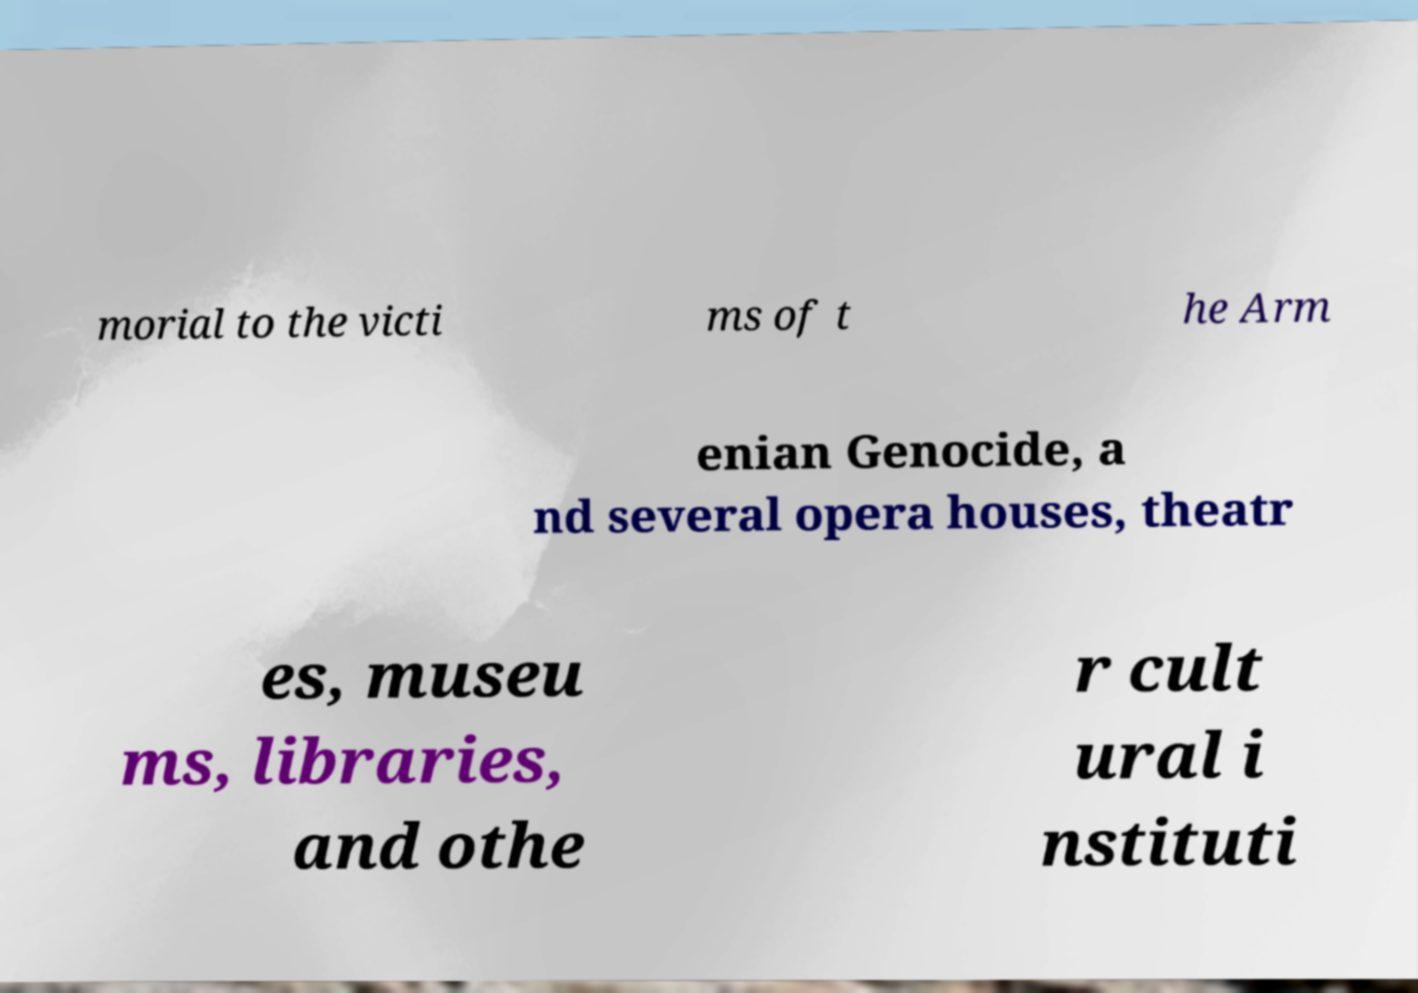What messages or text are displayed in this image? I need them in a readable, typed format. morial to the victi ms of t he Arm enian Genocide, a nd several opera houses, theatr es, museu ms, libraries, and othe r cult ural i nstituti 